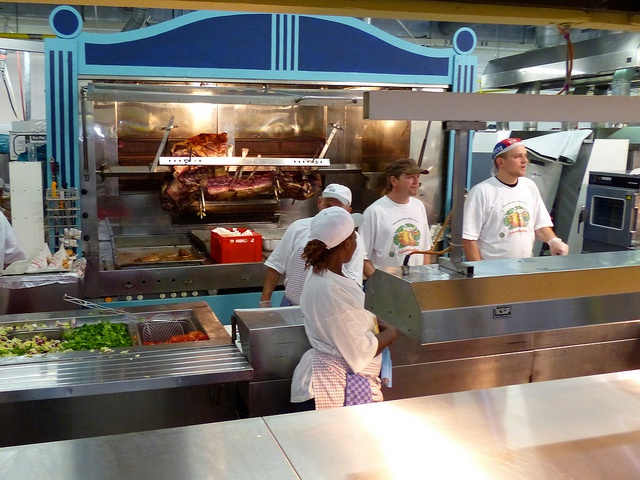Describe the objects in this image and their specific colors. I can see people in olive, darkgray, pink, tan, and black tones, people in olive, lightgray, darkgray, brown, and tan tones, oven in olive, black, gray, and maroon tones, people in olive, lightgray, darkgray, brown, and maroon tones, and microwave in olive, black, gray, and darkblue tones in this image. 